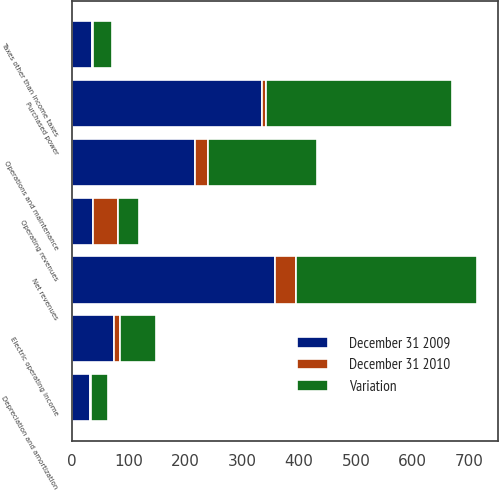<chart> <loc_0><loc_0><loc_500><loc_500><stacked_bar_chart><ecel><fcel>Operating revenues<fcel>Purchased power<fcel>Net revenues<fcel>Operations and maintenance<fcel>Depreciation and amortization<fcel>Taxes other than income taxes<fcel>Electric operating income<nl><fcel>December 31 2009<fcel>37<fcel>335<fcel>357<fcel>216<fcel>32<fcel>35<fcel>74<nl><fcel>Variation<fcel>37<fcel>328<fcel>320<fcel>193<fcel>30<fcel>33<fcel>64<nl><fcel>December 31 2010<fcel>44<fcel>7<fcel>37<fcel>23<fcel>2<fcel>2<fcel>10<nl></chart> 